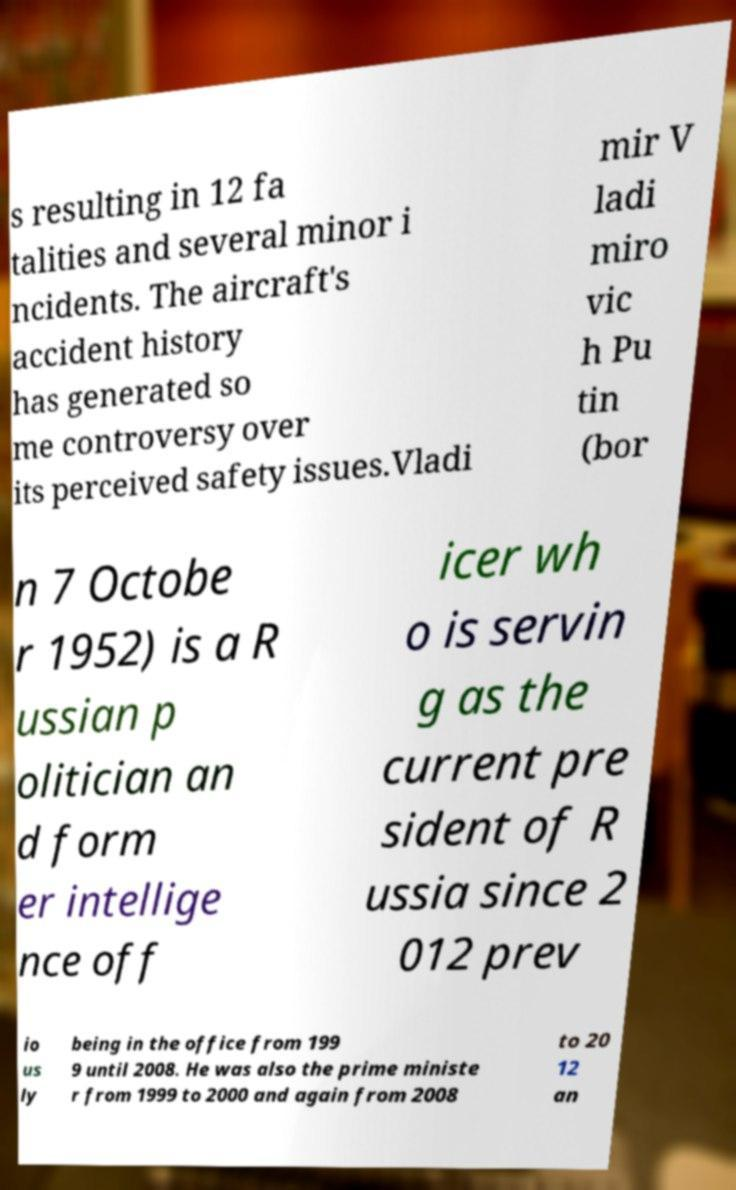Can you accurately transcribe the text from the provided image for me? s resulting in 12 fa talities and several minor i ncidents. The aircraft's accident history has generated so me controversy over its perceived safety issues.Vladi mir V ladi miro vic h Pu tin (bor n 7 Octobe r 1952) is a R ussian p olitician an d form er intellige nce off icer wh o is servin g as the current pre sident of R ussia since 2 012 prev io us ly being in the office from 199 9 until 2008. He was also the prime ministe r from 1999 to 2000 and again from 2008 to 20 12 an 